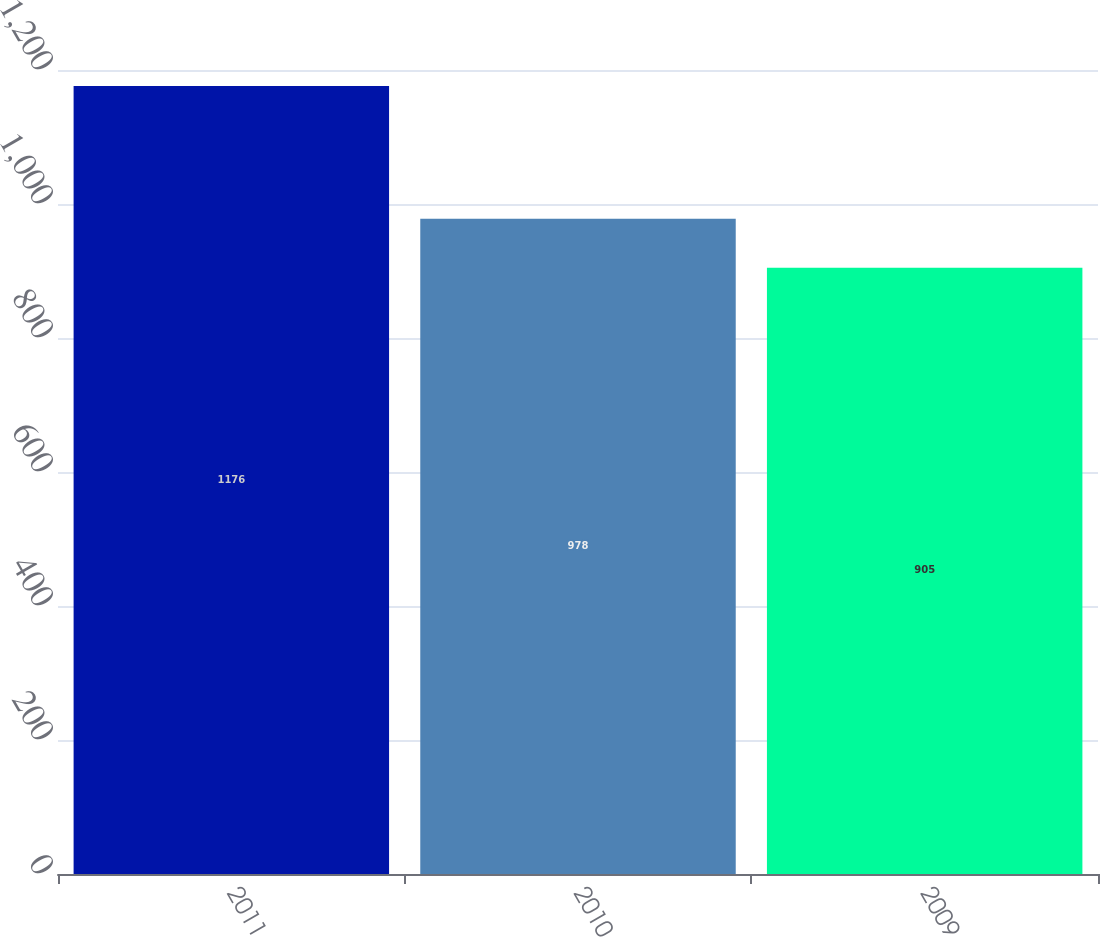Convert chart to OTSL. <chart><loc_0><loc_0><loc_500><loc_500><bar_chart><fcel>2011<fcel>2010<fcel>2009<nl><fcel>1176<fcel>978<fcel>905<nl></chart> 